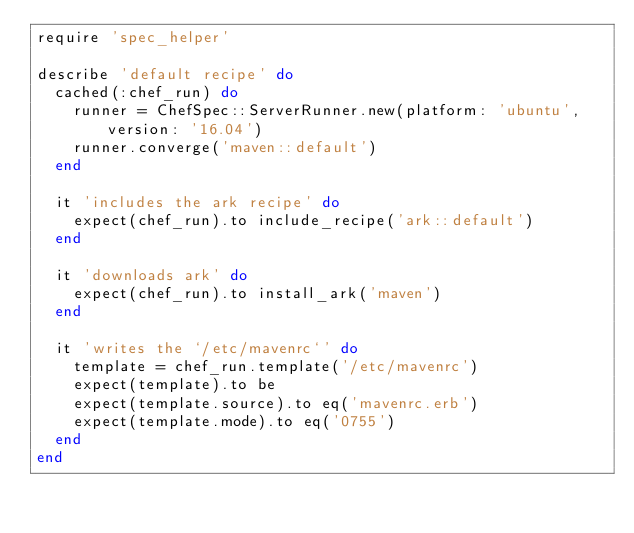<code> <loc_0><loc_0><loc_500><loc_500><_Ruby_>require 'spec_helper'

describe 'default recipe' do
  cached(:chef_run) do
    runner = ChefSpec::ServerRunner.new(platform: 'ubuntu', version: '16.04')
    runner.converge('maven::default')
  end

  it 'includes the ark recipe' do
    expect(chef_run).to include_recipe('ark::default')
  end

  it 'downloads ark' do
    expect(chef_run).to install_ark('maven')
  end

  it 'writes the `/etc/mavenrc`' do
    template = chef_run.template('/etc/mavenrc')
    expect(template).to be
    expect(template.source).to eq('mavenrc.erb')
    expect(template.mode).to eq('0755')
  end
end
</code> 